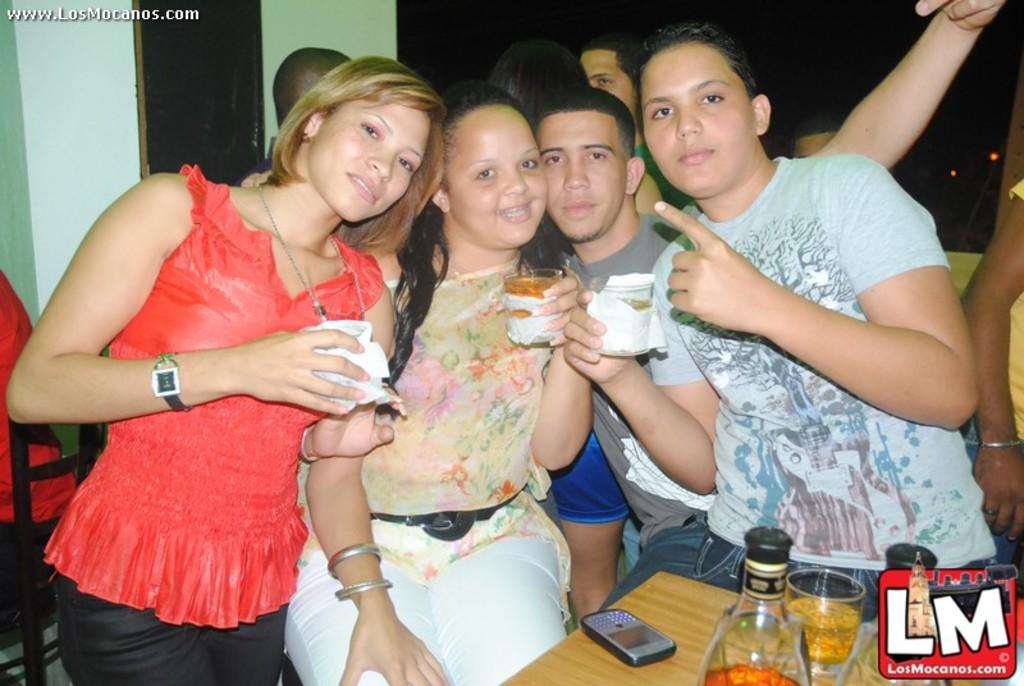How many people are in the image? There is a group of people in the image, but the exact number is not specified. What are the people holding in their hands? The people are holding glasses in their hands. What is located in front of the group of people? There is a table in front of the group of people. What can be seen on the table? There is a mobile, a glass, and wine bottles on the table. How does the group of people skate in the image? There is no indication in the image that the group of people is skating; they are holding glasses and standing near a table. 